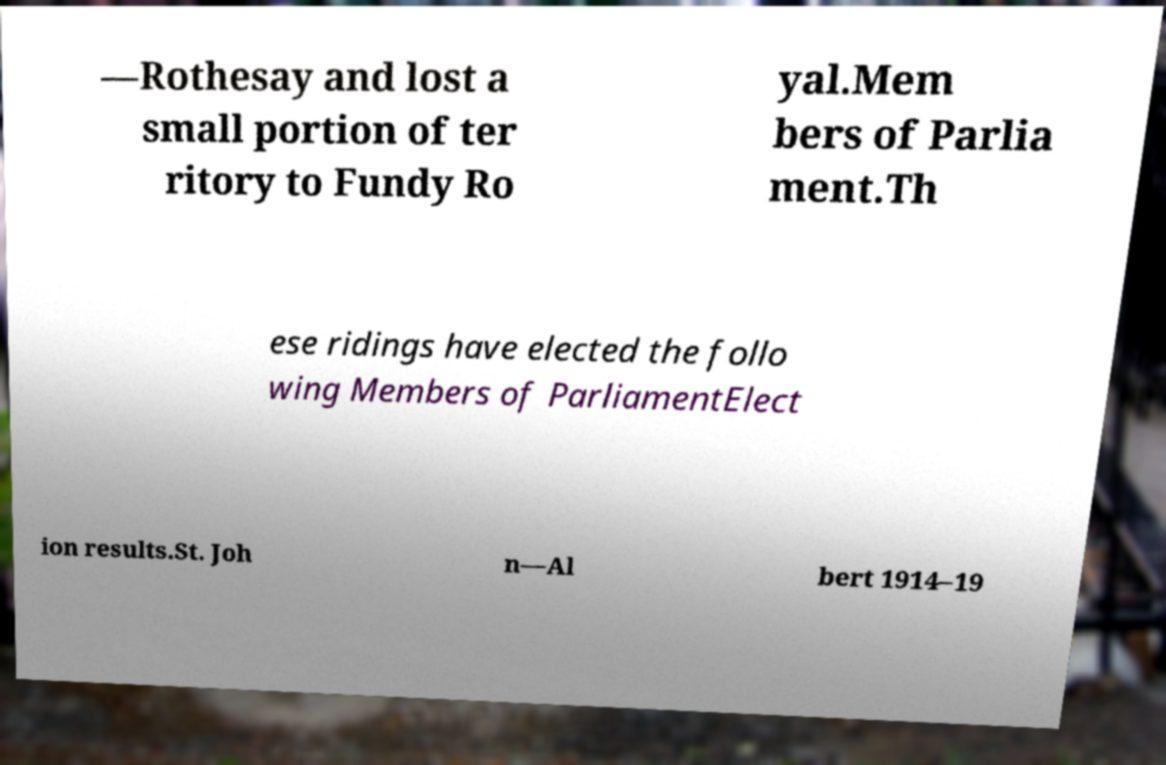For documentation purposes, I need the text within this image transcribed. Could you provide that? —Rothesay and lost a small portion of ter ritory to Fundy Ro yal.Mem bers of Parlia ment.Th ese ridings have elected the follo wing Members of ParliamentElect ion results.St. Joh n—Al bert 1914–19 